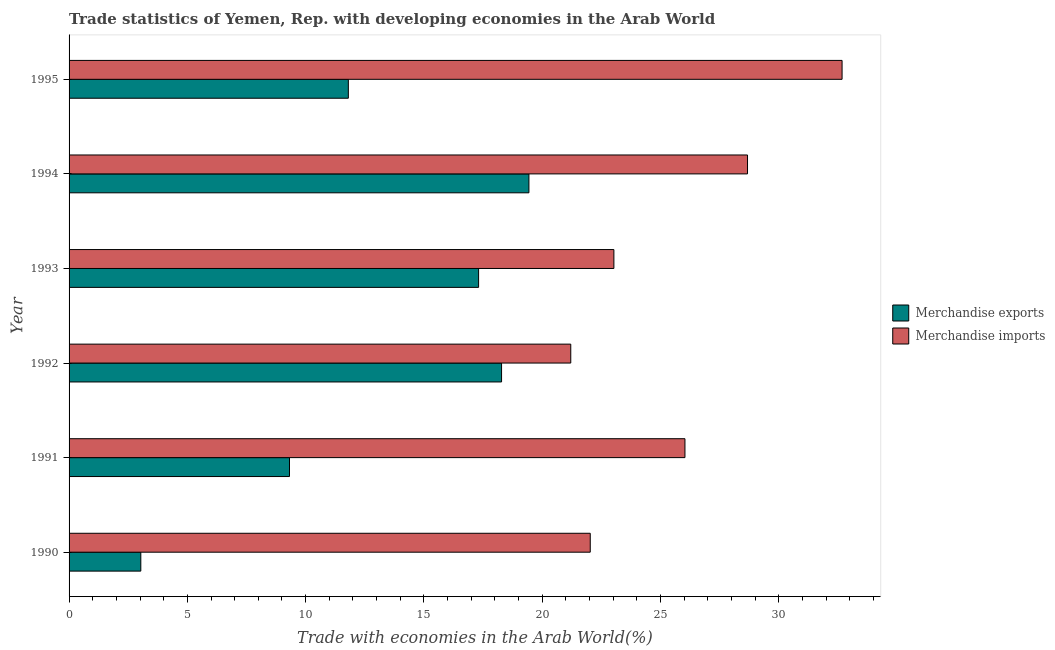How many different coloured bars are there?
Make the answer very short. 2. Are the number of bars per tick equal to the number of legend labels?
Your answer should be compact. Yes. In how many cases, is the number of bars for a given year not equal to the number of legend labels?
Your answer should be compact. 0. What is the merchandise exports in 1995?
Keep it short and to the point. 11.81. Across all years, what is the maximum merchandise imports?
Your answer should be compact. 32.68. Across all years, what is the minimum merchandise imports?
Your answer should be very brief. 21.21. What is the total merchandise exports in the graph?
Ensure brevity in your answer.  79.19. What is the difference between the merchandise exports in 1995 and the merchandise imports in 1993?
Keep it short and to the point. -11.23. What is the average merchandise imports per year?
Provide a succinct answer. 25.61. In the year 1991, what is the difference between the merchandise exports and merchandise imports?
Keep it short and to the point. -16.72. In how many years, is the merchandise exports greater than 25 %?
Ensure brevity in your answer.  0. What is the ratio of the merchandise imports in 1993 to that in 1995?
Ensure brevity in your answer.  0.7. Is the difference between the merchandise imports in 1992 and 1994 greater than the difference between the merchandise exports in 1992 and 1994?
Keep it short and to the point. No. What is the difference between the highest and the second highest merchandise imports?
Give a very brief answer. 4. What is the difference between the highest and the lowest merchandise imports?
Keep it short and to the point. 11.47. In how many years, is the merchandise imports greater than the average merchandise imports taken over all years?
Provide a short and direct response. 3. Is the sum of the merchandise imports in 1990 and 1994 greater than the maximum merchandise exports across all years?
Your answer should be compact. Yes. What does the 2nd bar from the top in 1994 represents?
Your answer should be very brief. Merchandise exports. What does the 2nd bar from the bottom in 1993 represents?
Make the answer very short. Merchandise imports. Are all the bars in the graph horizontal?
Keep it short and to the point. Yes. How many years are there in the graph?
Keep it short and to the point. 6. Are the values on the major ticks of X-axis written in scientific E-notation?
Ensure brevity in your answer.  No. Does the graph contain any zero values?
Give a very brief answer. No. Does the graph contain grids?
Provide a short and direct response. No. Where does the legend appear in the graph?
Your answer should be compact. Center right. How many legend labels are there?
Your answer should be very brief. 2. How are the legend labels stacked?
Your answer should be very brief. Vertical. What is the title of the graph?
Your answer should be compact. Trade statistics of Yemen, Rep. with developing economies in the Arab World. Does "Constant 2005 US$" appear as one of the legend labels in the graph?
Your answer should be very brief. No. What is the label or title of the X-axis?
Your answer should be very brief. Trade with economies in the Arab World(%). What is the Trade with economies in the Arab World(%) of Merchandise exports in 1990?
Your answer should be compact. 3.03. What is the Trade with economies in the Arab World(%) in Merchandise imports in 1990?
Provide a succinct answer. 22.03. What is the Trade with economies in the Arab World(%) in Merchandise exports in 1991?
Give a very brief answer. 9.32. What is the Trade with economies in the Arab World(%) of Merchandise imports in 1991?
Provide a short and direct response. 26.04. What is the Trade with economies in the Arab World(%) of Merchandise exports in 1992?
Offer a terse response. 18.28. What is the Trade with economies in the Arab World(%) in Merchandise imports in 1992?
Your answer should be very brief. 21.21. What is the Trade with economies in the Arab World(%) of Merchandise exports in 1993?
Keep it short and to the point. 17.31. What is the Trade with economies in the Arab World(%) of Merchandise imports in 1993?
Your answer should be very brief. 23.03. What is the Trade with economies in the Arab World(%) of Merchandise exports in 1994?
Ensure brevity in your answer.  19.44. What is the Trade with economies in the Arab World(%) of Merchandise imports in 1994?
Ensure brevity in your answer.  28.68. What is the Trade with economies in the Arab World(%) in Merchandise exports in 1995?
Provide a short and direct response. 11.81. What is the Trade with economies in the Arab World(%) in Merchandise imports in 1995?
Make the answer very short. 32.68. Across all years, what is the maximum Trade with economies in the Arab World(%) in Merchandise exports?
Make the answer very short. 19.44. Across all years, what is the maximum Trade with economies in the Arab World(%) of Merchandise imports?
Give a very brief answer. 32.68. Across all years, what is the minimum Trade with economies in the Arab World(%) in Merchandise exports?
Keep it short and to the point. 3.03. Across all years, what is the minimum Trade with economies in the Arab World(%) in Merchandise imports?
Keep it short and to the point. 21.21. What is the total Trade with economies in the Arab World(%) in Merchandise exports in the graph?
Make the answer very short. 79.19. What is the total Trade with economies in the Arab World(%) of Merchandise imports in the graph?
Your answer should be very brief. 153.67. What is the difference between the Trade with economies in the Arab World(%) of Merchandise exports in 1990 and that in 1991?
Provide a short and direct response. -6.29. What is the difference between the Trade with economies in the Arab World(%) of Merchandise imports in 1990 and that in 1991?
Provide a short and direct response. -4. What is the difference between the Trade with economies in the Arab World(%) of Merchandise exports in 1990 and that in 1992?
Keep it short and to the point. -15.25. What is the difference between the Trade with economies in the Arab World(%) in Merchandise imports in 1990 and that in 1992?
Your answer should be very brief. 0.82. What is the difference between the Trade with economies in the Arab World(%) of Merchandise exports in 1990 and that in 1993?
Your answer should be very brief. -14.28. What is the difference between the Trade with economies in the Arab World(%) of Merchandise imports in 1990 and that in 1993?
Give a very brief answer. -1. What is the difference between the Trade with economies in the Arab World(%) in Merchandise exports in 1990 and that in 1994?
Keep it short and to the point. -16.41. What is the difference between the Trade with economies in the Arab World(%) in Merchandise imports in 1990 and that in 1994?
Offer a very short reply. -6.65. What is the difference between the Trade with economies in the Arab World(%) of Merchandise exports in 1990 and that in 1995?
Your answer should be compact. -8.77. What is the difference between the Trade with economies in the Arab World(%) of Merchandise imports in 1990 and that in 1995?
Your answer should be very brief. -10.65. What is the difference between the Trade with economies in the Arab World(%) in Merchandise exports in 1991 and that in 1992?
Offer a terse response. -8.96. What is the difference between the Trade with economies in the Arab World(%) in Merchandise imports in 1991 and that in 1992?
Offer a very short reply. 4.83. What is the difference between the Trade with economies in the Arab World(%) of Merchandise exports in 1991 and that in 1993?
Ensure brevity in your answer.  -7.99. What is the difference between the Trade with economies in the Arab World(%) of Merchandise imports in 1991 and that in 1993?
Provide a succinct answer. 3. What is the difference between the Trade with economies in the Arab World(%) in Merchandise exports in 1991 and that in 1994?
Your answer should be compact. -10.12. What is the difference between the Trade with economies in the Arab World(%) in Merchandise imports in 1991 and that in 1994?
Offer a terse response. -2.65. What is the difference between the Trade with economies in the Arab World(%) in Merchandise exports in 1991 and that in 1995?
Offer a very short reply. -2.49. What is the difference between the Trade with economies in the Arab World(%) of Merchandise imports in 1991 and that in 1995?
Offer a terse response. -6.64. What is the difference between the Trade with economies in the Arab World(%) in Merchandise exports in 1992 and that in 1993?
Offer a very short reply. 0.97. What is the difference between the Trade with economies in the Arab World(%) in Merchandise imports in 1992 and that in 1993?
Keep it short and to the point. -1.82. What is the difference between the Trade with economies in the Arab World(%) of Merchandise exports in 1992 and that in 1994?
Offer a very short reply. -1.16. What is the difference between the Trade with economies in the Arab World(%) of Merchandise imports in 1992 and that in 1994?
Offer a very short reply. -7.47. What is the difference between the Trade with economies in the Arab World(%) of Merchandise exports in 1992 and that in 1995?
Offer a terse response. 6.48. What is the difference between the Trade with economies in the Arab World(%) in Merchandise imports in 1992 and that in 1995?
Your response must be concise. -11.47. What is the difference between the Trade with economies in the Arab World(%) in Merchandise exports in 1993 and that in 1994?
Your response must be concise. -2.13. What is the difference between the Trade with economies in the Arab World(%) of Merchandise imports in 1993 and that in 1994?
Provide a succinct answer. -5.65. What is the difference between the Trade with economies in the Arab World(%) in Merchandise exports in 1993 and that in 1995?
Your response must be concise. 5.51. What is the difference between the Trade with economies in the Arab World(%) of Merchandise imports in 1993 and that in 1995?
Your answer should be very brief. -9.65. What is the difference between the Trade with economies in the Arab World(%) of Merchandise exports in 1994 and that in 1995?
Provide a short and direct response. 7.63. What is the difference between the Trade with economies in the Arab World(%) in Merchandise imports in 1994 and that in 1995?
Provide a short and direct response. -4. What is the difference between the Trade with economies in the Arab World(%) of Merchandise exports in 1990 and the Trade with economies in the Arab World(%) of Merchandise imports in 1991?
Your response must be concise. -23. What is the difference between the Trade with economies in the Arab World(%) of Merchandise exports in 1990 and the Trade with economies in the Arab World(%) of Merchandise imports in 1992?
Provide a succinct answer. -18.18. What is the difference between the Trade with economies in the Arab World(%) of Merchandise exports in 1990 and the Trade with economies in the Arab World(%) of Merchandise imports in 1993?
Offer a very short reply. -20. What is the difference between the Trade with economies in the Arab World(%) of Merchandise exports in 1990 and the Trade with economies in the Arab World(%) of Merchandise imports in 1994?
Make the answer very short. -25.65. What is the difference between the Trade with economies in the Arab World(%) in Merchandise exports in 1990 and the Trade with economies in the Arab World(%) in Merchandise imports in 1995?
Your answer should be very brief. -29.65. What is the difference between the Trade with economies in the Arab World(%) of Merchandise exports in 1991 and the Trade with economies in the Arab World(%) of Merchandise imports in 1992?
Offer a very short reply. -11.89. What is the difference between the Trade with economies in the Arab World(%) of Merchandise exports in 1991 and the Trade with economies in the Arab World(%) of Merchandise imports in 1993?
Give a very brief answer. -13.71. What is the difference between the Trade with economies in the Arab World(%) in Merchandise exports in 1991 and the Trade with economies in the Arab World(%) in Merchandise imports in 1994?
Offer a terse response. -19.36. What is the difference between the Trade with economies in the Arab World(%) of Merchandise exports in 1991 and the Trade with economies in the Arab World(%) of Merchandise imports in 1995?
Your answer should be very brief. -23.36. What is the difference between the Trade with economies in the Arab World(%) of Merchandise exports in 1992 and the Trade with economies in the Arab World(%) of Merchandise imports in 1993?
Ensure brevity in your answer.  -4.75. What is the difference between the Trade with economies in the Arab World(%) in Merchandise exports in 1992 and the Trade with economies in the Arab World(%) in Merchandise imports in 1994?
Give a very brief answer. -10.4. What is the difference between the Trade with economies in the Arab World(%) of Merchandise exports in 1992 and the Trade with economies in the Arab World(%) of Merchandise imports in 1995?
Provide a succinct answer. -14.4. What is the difference between the Trade with economies in the Arab World(%) of Merchandise exports in 1993 and the Trade with economies in the Arab World(%) of Merchandise imports in 1994?
Your response must be concise. -11.37. What is the difference between the Trade with economies in the Arab World(%) of Merchandise exports in 1993 and the Trade with economies in the Arab World(%) of Merchandise imports in 1995?
Your response must be concise. -15.37. What is the difference between the Trade with economies in the Arab World(%) in Merchandise exports in 1994 and the Trade with economies in the Arab World(%) in Merchandise imports in 1995?
Provide a short and direct response. -13.24. What is the average Trade with economies in the Arab World(%) in Merchandise exports per year?
Provide a short and direct response. 13.2. What is the average Trade with economies in the Arab World(%) of Merchandise imports per year?
Offer a very short reply. 25.61. In the year 1990, what is the difference between the Trade with economies in the Arab World(%) in Merchandise exports and Trade with economies in the Arab World(%) in Merchandise imports?
Provide a short and direct response. -19. In the year 1991, what is the difference between the Trade with economies in the Arab World(%) of Merchandise exports and Trade with economies in the Arab World(%) of Merchandise imports?
Ensure brevity in your answer.  -16.72. In the year 1992, what is the difference between the Trade with economies in the Arab World(%) in Merchandise exports and Trade with economies in the Arab World(%) in Merchandise imports?
Provide a succinct answer. -2.93. In the year 1993, what is the difference between the Trade with economies in the Arab World(%) of Merchandise exports and Trade with economies in the Arab World(%) of Merchandise imports?
Give a very brief answer. -5.72. In the year 1994, what is the difference between the Trade with economies in the Arab World(%) in Merchandise exports and Trade with economies in the Arab World(%) in Merchandise imports?
Give a very brief answer. -9.24. In the year 1995, what is the difference between the Trade with economies in the Arab World(%) in Merchandise exports and Trade with economies in the Arab World(%) in Merchandise imports?
Offer a terse response. -20.87. What is the ratio of the Trade with economies in the Arab World(%) of Merchandise exports in 1990 to that in 1991?
Give a very brief answer. 0.33. What is the ratio of the Trade with economies in the Arab World(%) in Merchandise imports in 1990 to that in 1991?
Ensure brevity in your answer.  0.85. What is the ratio of the Trade with economies in the Arab World(%) of Merchandise exports in 1990 to that in 1992?
Your response must be concise. 0.17. What is the ratio of the Trade with economies in the Arab World(%) in Merchandise imports in 1990 to that in 1992?
Make the answer very short. 1.04. What is the ratio of the Trade with economies in the Arab World(%) of Merchandise exports in 1990 to that in 1993?
Your answer should be very brief. 0.18. What is the ratio of the Trade with economies in the Arab World(%) in Merchandise imports in 1990 to that in 1993?
Offer a terse response. 0.96. What is the ratio of the Trade with economies in the Arab World(%) of Merchandise exports in 1990 to that in 1994?
Provide a short and direct response. 0.16. What is the ratio of the Trade with economies in the Arab World(%) of Merchandise imports in 1990 to that in 1994?
Your answer should be very brief. 0.77. What is the ratio of the Trade with economies in the Arab World(%) of Merchandise exports in 1990 to that in 1995?
Your response must be concise. 0.26. What is the ratio of the Trade with economies in the Arab World(%) of Merchandise imports in 1990 to that in 1995?
Give a very brief answer. 0.67. What is the ratio of the Trade with economies in the Arab World(%) of Merchandise exports in 1991 to that in 1992?
Offer a terse response. 0.51. What is the ratio of the Trade with economies in the Arab World(%) of Merchandise imports in 1991 to that in 1992?
Provide a short and direct response. 1.23. What is the ratio of the Trade with economies in the Arab World(%) of Merchandise exports in 1991 to that in 1993?
Provide a succinct answer. 0.54. What is the ratio of the Trade with economies in the Arab World(%) of Merchandise imports in 1991 to that in 1993?
Offer a very short reply. 1.13. What is the ratio of the Trade with economies in the Arab World(%) in Merchandise exports in 1991 to that in 1994?
Your answer should be very brief. 0.48. What is the ratio of the Trade with economies in the Arab World(%) in Merchandise imports in 1991 to that in 1994?
Offer a very short reply. 0.91. What is the ratio of the Trade with economies in the Arab World(%) in Merchandise exports in 1991 to that in 1995?
Make the answer very short. 0.79. What is the ratio of the Trade with economies in the Arab World(%) of Merchandise imports in 1991 to that in 1995?
Provide a succinct answer. 0.8. What is the ratio of the Trade with economies in the Arab World(%) of Merchandise exports in 1992 to that in 1993?
Give a very brief answer. 1.06. What is the ratio of the Trade with economies in the Arab World(%) in Merchandise imports in 1992 to that in 1993?
Offer a terse response. 0.92. What is the ratio of the Trade with economies in the Arab World(%) in Merchandise exports in 1992 to that in 1994?
Ensure brevity in your answer.  0.94. What is the ratio of the Trade with economies in the Arab World(%) of Merchandise imports in 1992 to that in 1994?
Ensure brevity in your answer.  0.74. What is the ratio of the Trade with economies in the Arab World(%) in Merchandise exports in 1992 to that in 1995?
Provide a short and direct response. 1.55. What is the ratio of the Trade with economies in the Arab World(%) of Merchandise imports in 1992 to that in 1995?
Provide a short and direct response. 0.65. What is the ratio of the Trade with economies in the Arab World(%) of Merchandise exports in 1993 to that in 1994?
Your response must be concise. 0.89. What is the ratio of the Trade with economies in the Arab World(%) of Merchandise imports in 1993 to that in 1994?
Your response must be concise. 0.8. What is the ratio of the Trade with economies in the Arab World(%) in Merchandise exports in 1993 to that in 1995?
Provide a succinct answer. 1.47. What is the ratio of the Trade with economies in the Arab World(%) of Merchandise imports in 1993 to that in 1995?
Provide a succinct answer. 0.7. What is the ratio of the Trade with economies in the Arab World(%) in Merchandise exports in 1994 to that in 1995?
Provide a short and direct response. 1.65. What is the ratio of the Trade with economies in the Arab World(%) of Merchandise imports in 1994 to that in 1995?
Your response must be concise. 0.88. What is the difference between the highest and the second highest Trade with economies in the Arab World(%) of Merchandise exports?
Provide a short and direct response. 1.16. What is the difference between the highest and the second highest Trade with economies in the Arab World(%) of Merchandise imports?
Offer a very short reply. 4. What is the difference between the highest and the lowest Trade with economies in the Arab World(%) of Merchandise exports?
Keep it short and to the point. 16.41. What is the difference between the highest and the lowest Trade with economies in the Arab World(%) in Merchandise imports?
Keep it short and to the point. 11.47. 